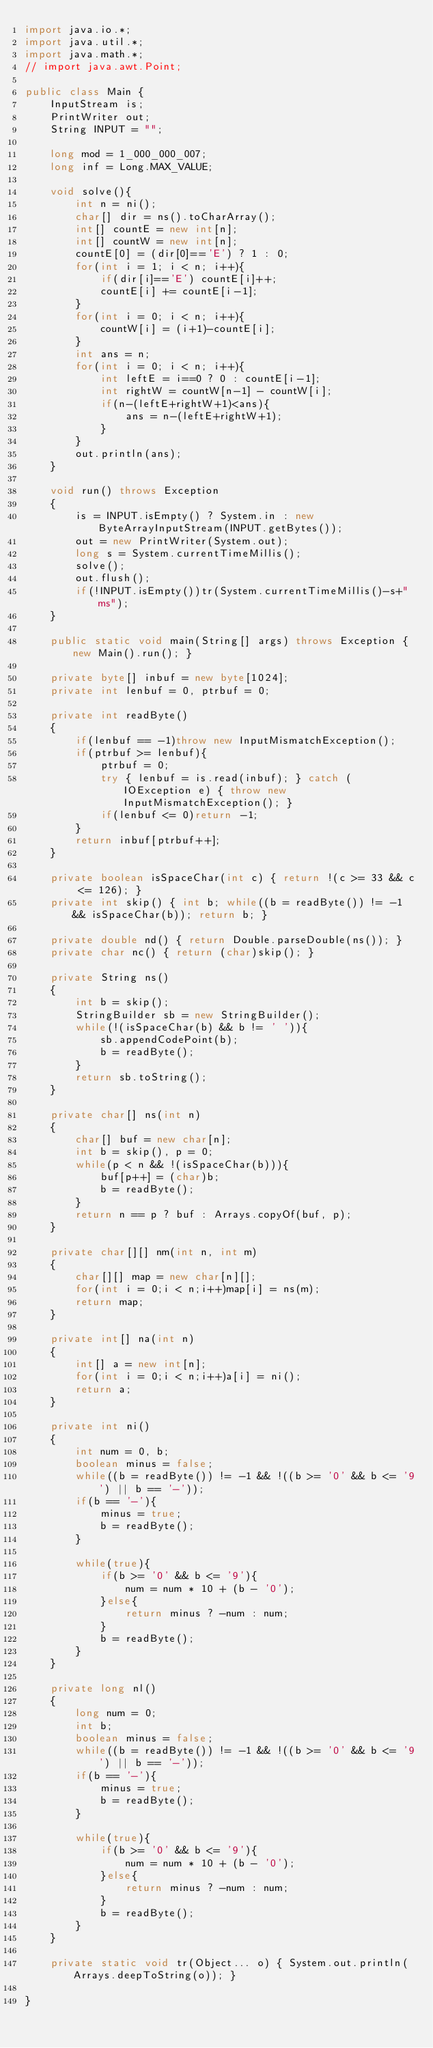Convert code to text. <code><loc_0><loc_0><loc_500><loc_500><_Java_>import java.io.*;
import java.util.*;
import java.math.*;
// import java.awt.Point;
 
public class Main {
    InputStream is;
    PrintWriter out;
    String INPUT = "";
 
    long mod = 1_000_000_007;
    long inf = Long.MAX_VALUE;

    void solve(){
        int n = ni();
        char[] dir = ns().toCharArray();
        int[] countE = new int[n];
        int[] countW = new int[n];
        countE[0] = (dir[0]=='E') ? 1 : 0;
        for(int i = 1; i < n; i++){
            if(dir[i]=='E') countE[i]++;
            countE[i] += countE[i-1];
        }
        for(int i = 0; i < n; i++){
            countW[i] = (i+1)-countE[i];
        }
        int ans = n;
        for(int i = 0; i < n; i++){
            int leftE = i==0 ? 0 : countE[i-1];
            int rightW = countW[n-1] - countW[i];
            if(n-(leftE+rightW+1)<ans){
                ans = n-(leftE+rightW+1);
            }
        }
        out.println(ans);
    }

    void run() throws Exception
    {
        is = INPUT.isEmpty() ? System.in : new ByteArrayInputStream(INPUT.getBytes());
        out = new PrintWriter(System.out);
        long s = System.currentTimeMillis();
        solve();
        out.flush();
        if(!INPUT.isEmpty())tr(System.currentTimeMillis()-s+"ms");
    }
    
    public static void main(String[] args) throws Exception { new Main().run(); }
    
    private byte[] inbuf = new byte[1024];
    private int lenbuf = 0, ptrbuf = 0;
    
    private int readByte()
    {
        if(lenbuf == -1)throw new InputMismatchException();
        if(ptrbuf >= lenbuf){
            ptrbuf = 0;
            try { lenbuf = is.read(inbuf); } catch (IOException e) { throw new InputMismatchException(); }
            if(lenbuf <= 0)return -1;
        }
        return inbuf[ptrbuf++];
    }
    
    private boolean isSpaceChar(int c) { return !(c >= 33 && c <= 126); }
    private int skip() { int b; while((b = readByte()) != -1 && isSpaceChar(b)); return b; }
    
    private double nd() { return Double.parseDouble(ns()); }
    private char nc() { return (char)skip(); }
    
    private String ns()
    {
        int b = skip();
        StringBuilder sb = new StringBuilder();
        while(!(isSpaceChar(b) && b != ' ')){
            sb.appendCodePoint(b);
            b = readByte();
        }
        return sb.toString();
    }
    
    private char[] ns(int n)
    {
        char[] buf = new char[n];
        int b = skip(), p = 0;
        while(p < n && !(isSpaceChar(b))){
            buf[p++] = (char)b;
            b = readByte();
        }
        return n == p ? buf : Arrays.copyOf(buf, p);
    }
    
    private char[][] nm(int n, int m)
    {
        char[][] map = new char[n][];
        for(int i = 0;i < n;i++)map[i] = ns(m);
        return map;
    }
    
    private int[] na(int n)
    {
        int[] a = new int[n];
        for(int i = 0;i < n;i++)a[i] = ni();
        return a;
    }
    
    private int ni()
    {
        int num = 0, b;
        boolean minus = false;
        while((b = readByte()) != -1 && !((b >= '0' && b <= '9') || b == '-'));
        if(b == '-'){
            minus = true;
            b = readByte();
        }
        
        while(true){
            if(b >= '0' && b <= '9'){
                num = num * 10 + (b - '0');
            }else{
                return minus ? -num : num;
            }
            b = readByte();
        }
    }
    
    private long nl()
    {
        long num = 0;
        int b;
        boolean minus = false;
        while((b = readByte()) != -1 && !((b >= '0' && b <= '9') || b == '-'));
        if(b == '-'){
            minus = true;
            b = readByte();
        }
        
        while(true){
            if(b >= '0' && b <= '9'){
                num = num * 10 + (b - '0');
            }else{
                return minus ? -num : num;
            }
            b = readByte();
        }
    }
    
    private static void tr(Object... o) { System.out.println(Arrays.deepToString(o)); }
 
}
</code> 